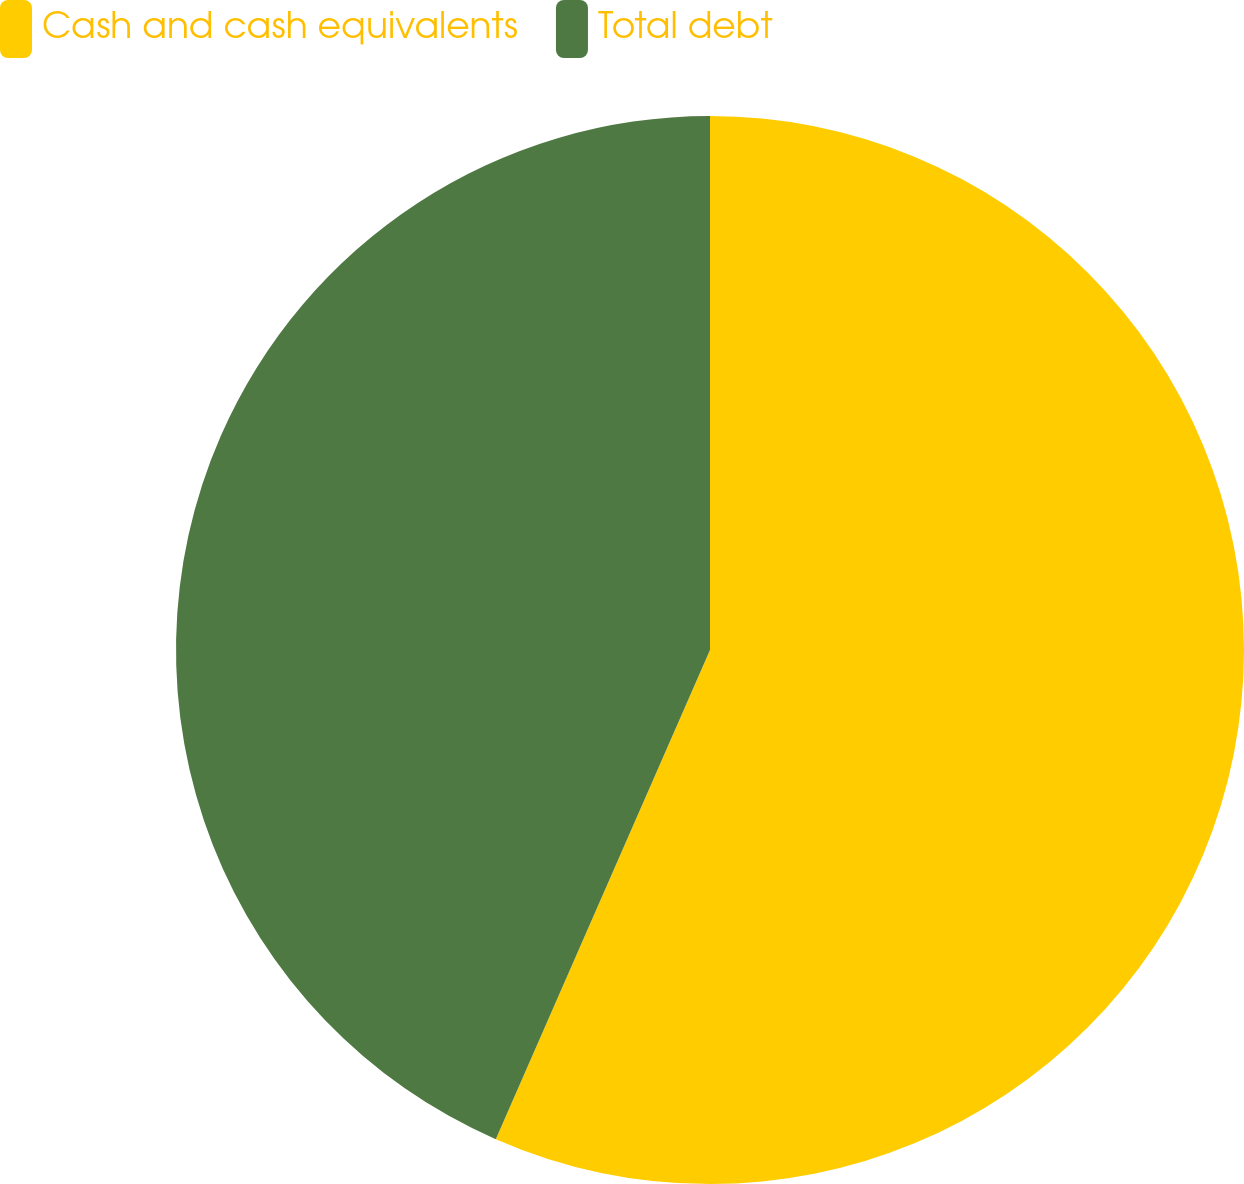Convert chart. <chart><loc_0><loc_0><loc_500><loc_500><pie_chart><fcel>Cash and cash equivalents<fcel>Total debt<nl><fcel>56.57%<fcel>43.43%<nl></chart> 